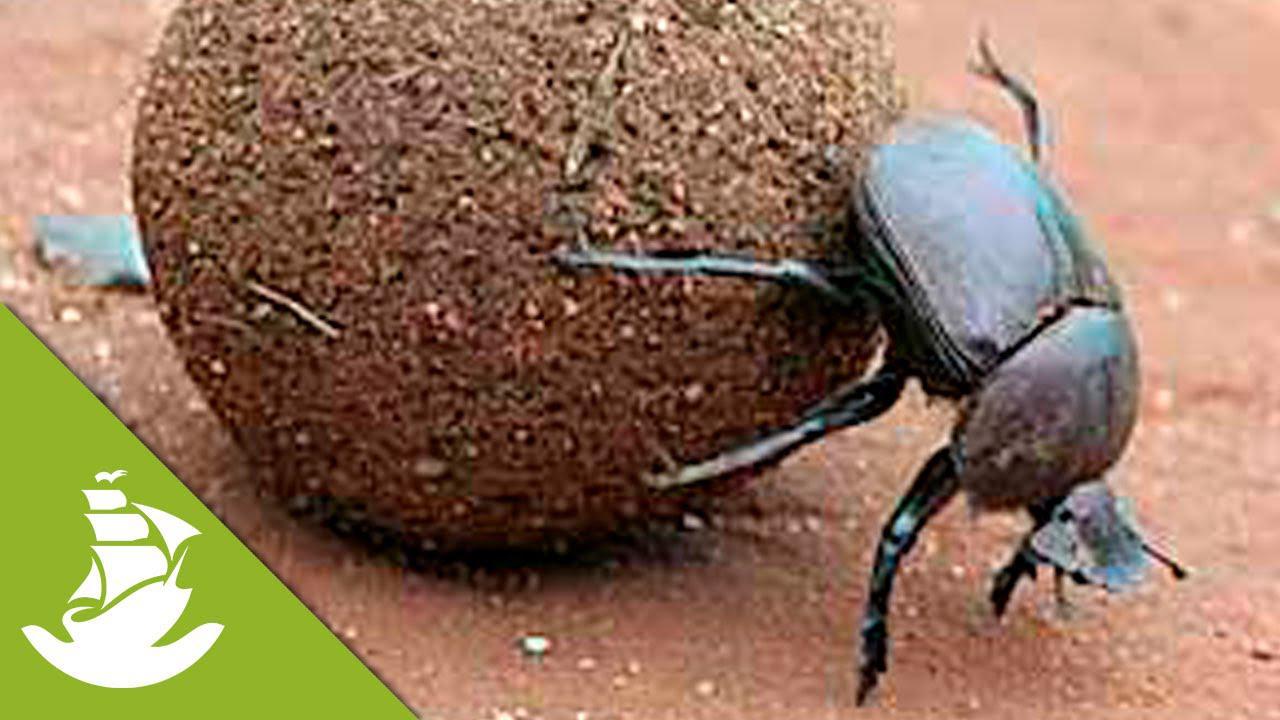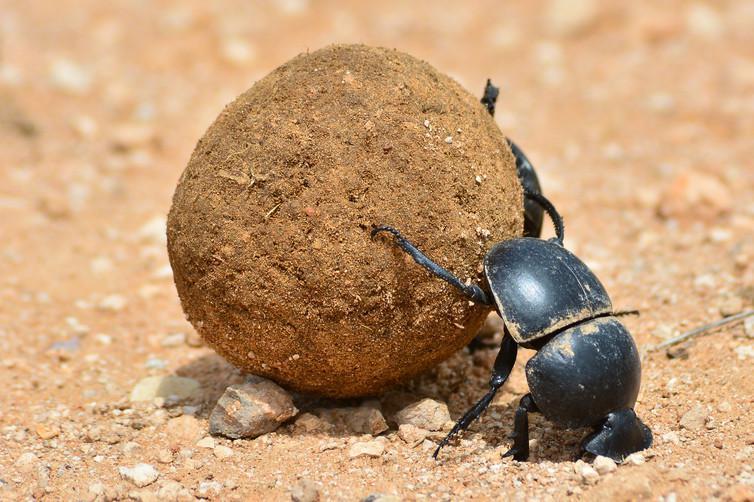The first image is the image on the left, the second image is the image on the right. For the images shown, is this caption "An image shows more than one beetle by a shape made of dung." true? Answer yes or no. No. The first image is the image on the left, the second image is the image on the right. Given the left and right images, does the statement "There are at least two insects in the image on the right." hold true? Answer yes or no. No. 